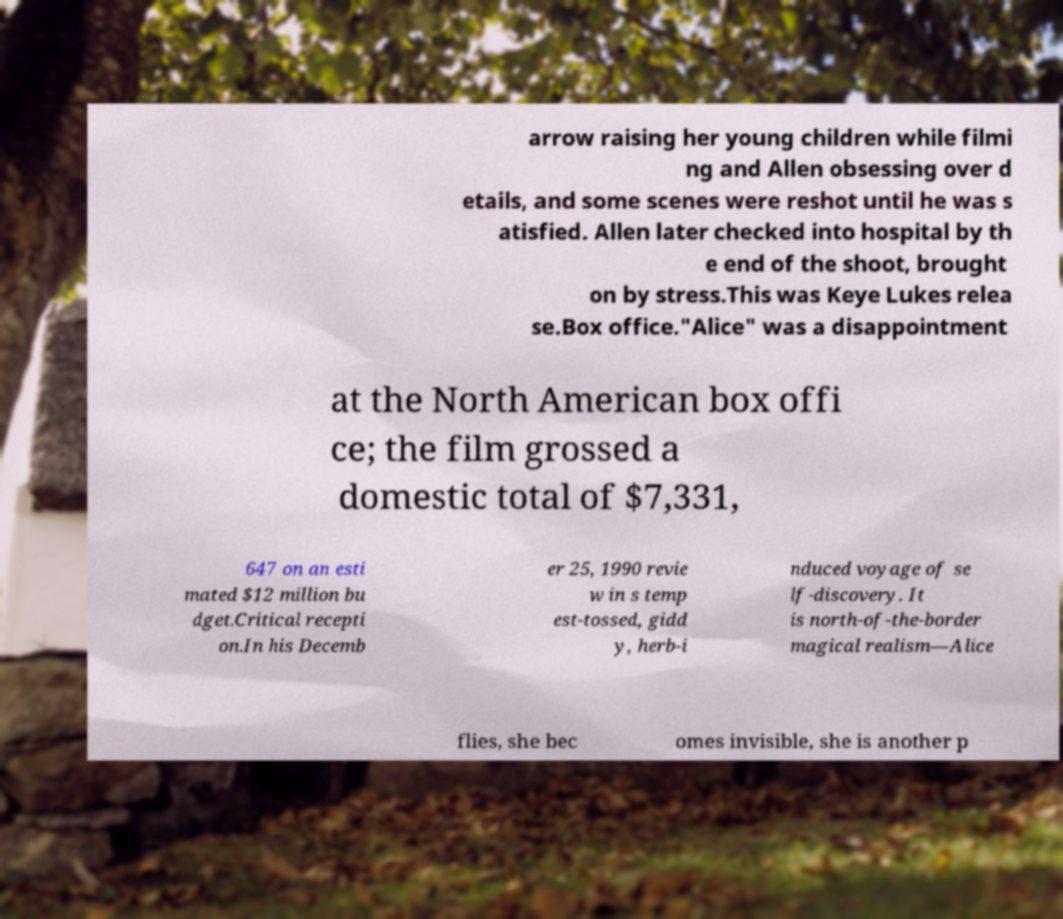What messages or text are displayed in this image? I need them in a readable, typed format. arrow raising her young children while filmi ng and Allen obsessing over d etails, and some scenes were reshot until he was s atisfied. Allen later checked into hospital by th e end of the shoot, brought on by stress.This was Keye Lukes relea se.Box office."Alice" was a disappointment at the North American box offi ce; the film grossed a domestic total of $7,331, 647 on an esti mated $12 million bu dget.Critical recepti on.In his Decemb er 25, 1990 revie w in s temp est-tossed, gidd y, herb-i nduced voyage of se lf-discovery. It is north-of-the-border magical realism—Alice flies, she bec omes invisible, she is another p 